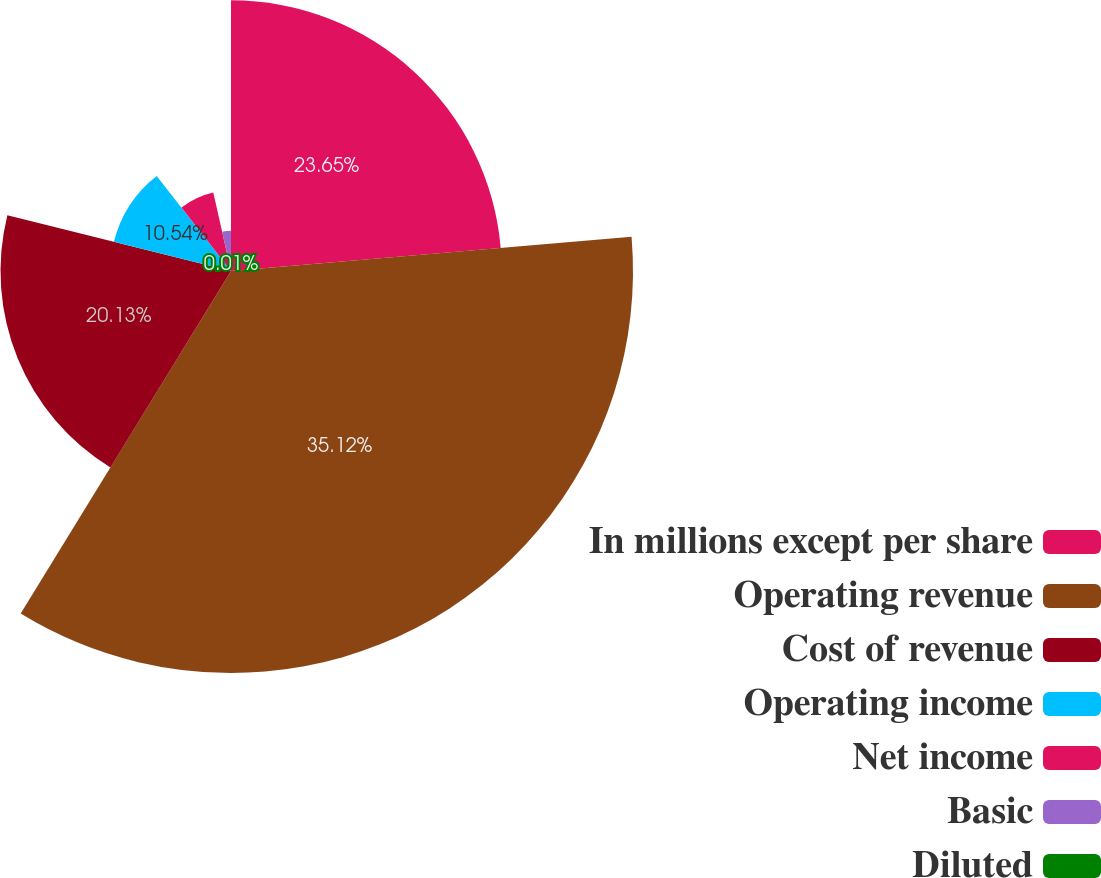<chart> <loc_0><loc_0><loc_500><loc_500><pie_chart><fcel>In millions except per share<fcel>Operating revenue<fcel>Cost of revenue<fcel>Operating income<fcel>Net income<fcel>Basic<fcel>Diluted<nl><fcel>23.64%<fcel>35.11%<fcel>20.13%<fcel>10.54%<fcel>7.03%<fcel>3.52%<fcel>0.01%<nl></chart> 